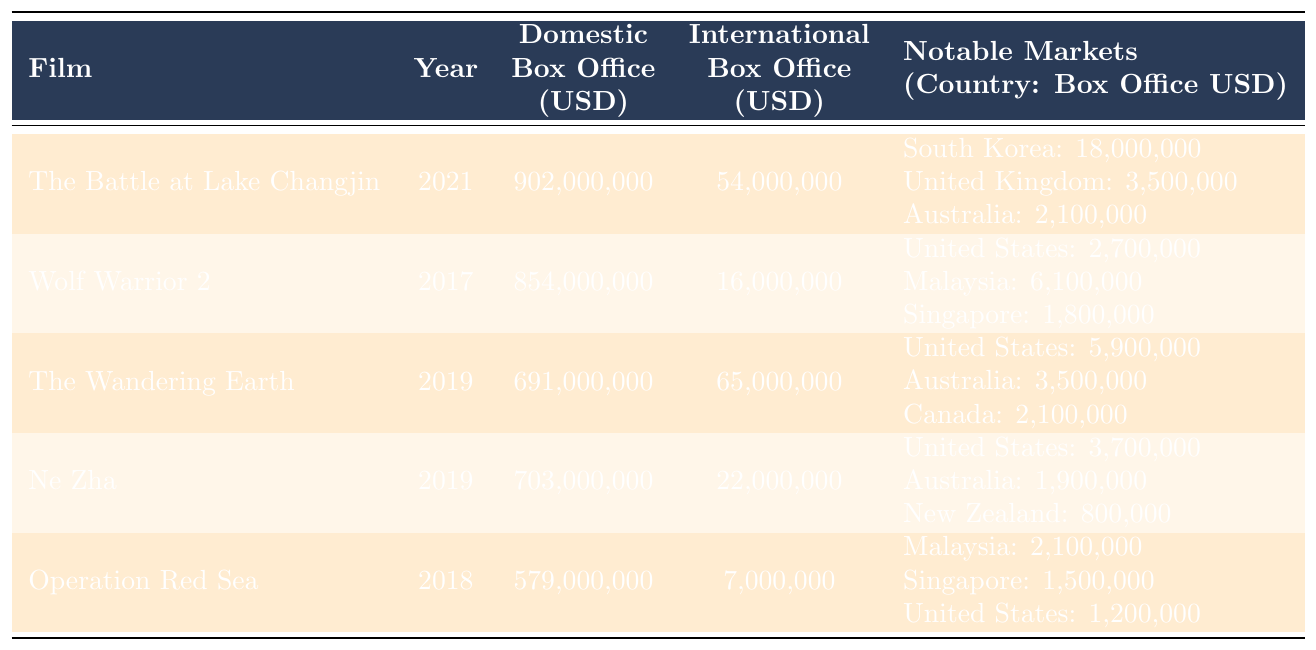What is the domestic box office of "The Battle at Lake Changjin"? The table shows that the domestic box office for "The Battle at Lake Changjin" is listed as 902,000,000 USD.
Answer: 902,000,000 USD Which film had the highest international box office? Looking at the international box office values in the table, "The Wandering Earth" has the highest value at 65,000,000 USD.
Answer: The Wandering Earth What is the total domestic box office of all films listed? Adding up the domestic box office for each film: 902,000,000 + 854,000,000 + 691,000,000 + 703,000,000 + 579,000,000 = 3,729,000,000 USD.
Answer: 3,729,000,000 USD Did "Operation Red Sea" earn more internationally than domestically? The table shows that "Operation Red Sea" earned 7,000,000 USD internationally and 579,000,000 USD domestically, so it did not earn more internationally.
Answer: No What was the combined international box office for "Ne Zha" and "Wolf Warrior 2"? Summing the international box office for "Ne Zha" (22,000,000 USD) and "Wolf Warrior 2" (16,000,000 USD) gives us: 22,000,000 + 16,000,000 = 38,000,000 USD.
Answer: 38,000,000 USD Which country contributed the most to "The Battle at Lake Changjin's" international box office? From the notable markets listed, South Korea contributed 18,000,000 USD, which is the highest among the countries mentioned for this film.
Answer: South Korea What is the average domestic box office among the films from 2017 to 2021? The domestic box office amounts for the films from 2017 to 2021 are: 854,000,000 (Wolf Warrior 2), 579,000,000 (Operation Red Sea), 691,000,000 (The Wandering Earth), 703,000,000 (Ne Zha), and 902,000,000 (The Battle at Lake Changjin). The average is calculated as follows: (854,000,000 + 579,000,000 + 691,000,000 + 703,000,000 + 902,000,000) / 5 = 745,000,000 USD.
Answer: 745,000,000 USD Which film had a higher international box office, "The Wandering Earth" or "Ne Zha"? The table indicates that "The Wandering Earth" had an international box office of 65,000,000 USD, while "Ne Zha" had 22,000,000 USD, therefore "The Wandering Earth" had the higher international box office.
Answer: The Wandering Earth What percentage of the total international box office does "Operation Red Sea" represent? The total international box office for all films is 54,000,000 (The Battle at Lake Changjin) + 16,000,000 (Wolf Warrior 2) + 65,000,000 (The Wandering Earth) + 22,000,000 (Ne Zha) + 7,000,000 (Operation Red Sea) = 164,000,000 USD. Since "Operation Red Sea" earned 7,000,000 USD, its percentage is (7,000,000 / 164,000,000) * 100 ≈ 4.27%.
Answer: Approximately 4.27% Which film released in 2019 generated the most domestic revenue? "The Wandering Earth" with 691,000,000 USD in domestic box office revenue surpasses "Ne Zha," which made 703,000,000 USD.
Answer: Ne Zha 